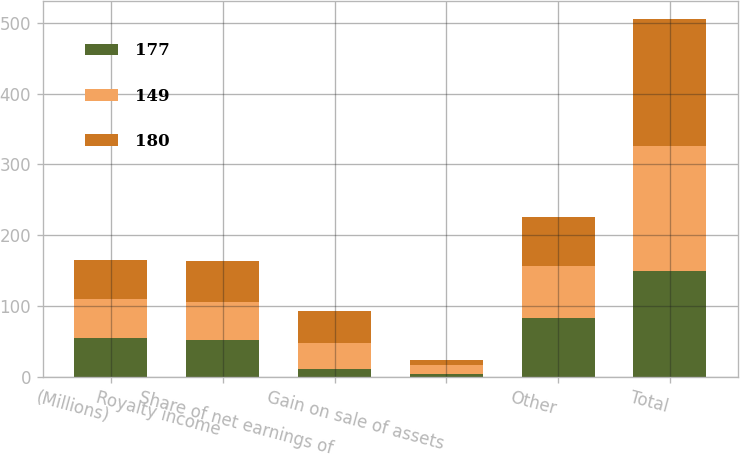Convert chart to OTSL. <chart><loc_0><loc_0><loc_500><loc_500><stacked_bar_chart><ecel><fcel>(Millions)<fcel>Royalty income<fcel>Share of net earnings of<fcel>Gain on sale of assets<fcel>Other<fcel>Total<nl><fcel>177<fcel>55<fcel>51<fcel>11<fcel>4<fcel>83<fcel>149<nl><fcel>149<fcel>55<fcel>55<fcel>37<fcel>12<fcel>73<fcel>177<nl><fcel>180<fcel>55<fcel>58<fcel>45<fcel>8<fcel>69<fcel>180<nl></chart> 